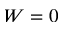<formula> <loc_0><loc_0><loc_500><loc_500>W = 0</formula> 